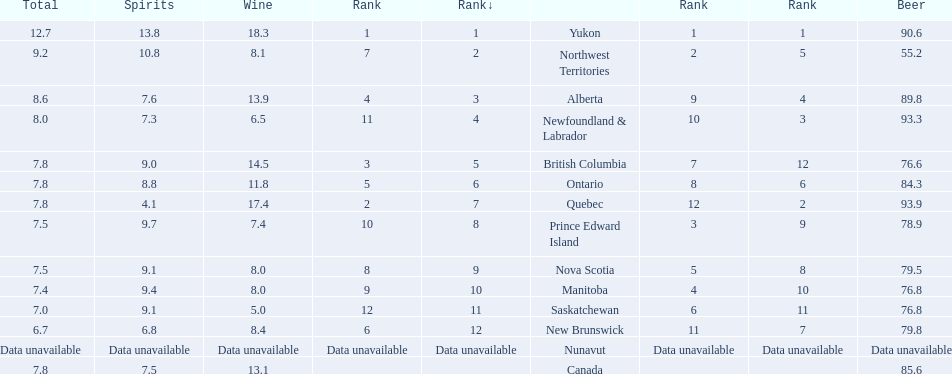Which country ranks #1 in alcoholic beverage consumption? Yukon. Of that country, how many total liters of spirits do they consume? 12.7. 